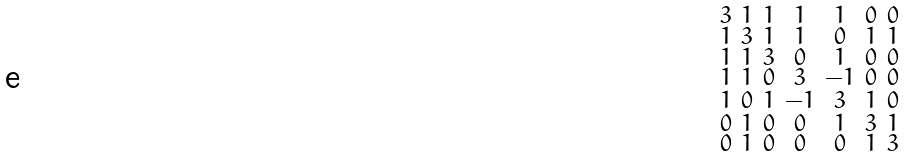Convert formula to latex. <formula><loc_0><loc_0><loc_500><loc_500>\begin{smallmatrix} 3 & 1 & 1 & 1 & 1 & 0 & 0 \\ 1 & 3 & 1 & 1 & 0 & 1 & 1 \\ 1 & 1 & 3 & 0 & 1 & 0 & 0 \\ 1 & 1 & 0 & 3 & - 1 & 0 & 0 \\ 1 & 0 & 1 & - 1 & 3 & 1 & 0 \\ 0 & 1 & 0 & 0 & 1 & 3 & 1 \\ 0 & 1 & 0 & 0 & 0 & 1 & 3 \end{smallmatrix}</formula> 